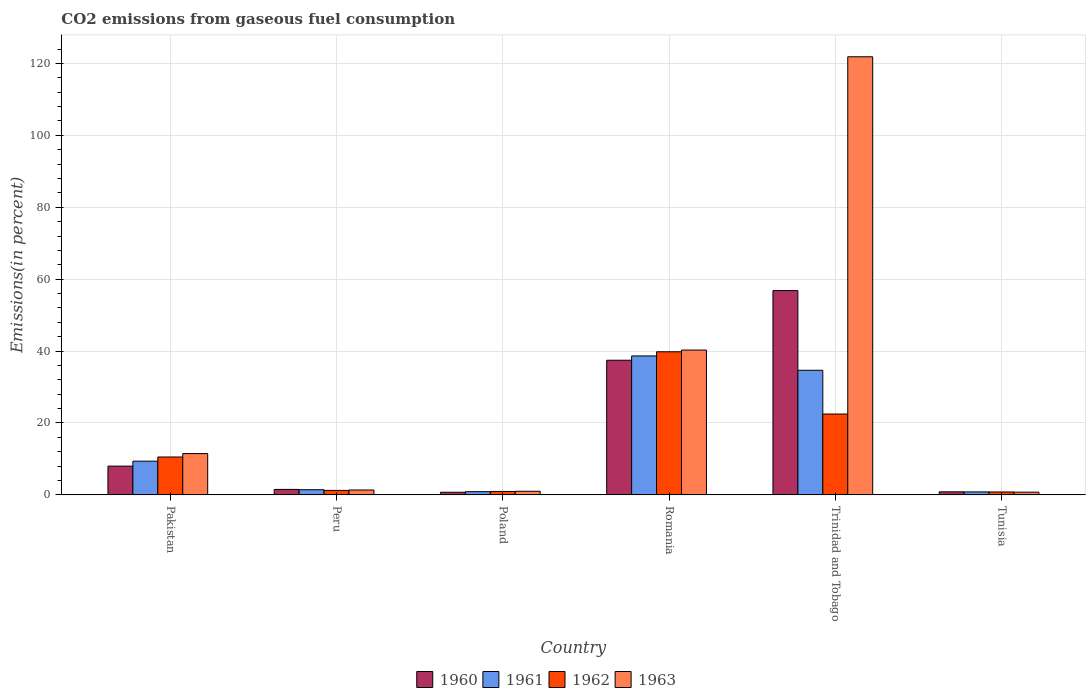Are the number of bars per tick equal to the number of legend labels?
Offer a very short reply. Yes. How many bars are there on the 6th tick from the right?
Provide a succinct answer. 4. What is the label of the 5th group of bars from the left?
Make the answer very short. Trinidad and Tobago. What is the total CO2 emitted in 1961 in Romania?
Provide a short and direct response. 38.65. Across all countries, what is the maximum total CO2 emitted in 1960?
Give a very brief answer. 56.82. Across all countries, what is the minimum total CO2 emitted in 1961?
Your answer should be very brief. 0.83. In which country was the total CO2 emitted in 1962 maximum?
Provide a succinct answer. Romania. In which country was the total CO2 emitted in 1963 minimum?
Provide a succinct answer. Tunisia. What is the total total CO2 emitted in 1963 in the graph?
Provide a short and direct response. 176.75. What is the difference between the total CO2 emitted in 1961 in Pakistan and that in Romania?
Your answer should be very brief. -29.26. What is the difference between the total CO2 emitted in 1960 in Romania and the total CO2 emitted in 1963 in Tunisia?
Keep it short and to the point. 36.7. What is the average total CO2 emitted in 1962 per country?
Your response must be concise. 12.64. What is the difference between the total CO2 emitted of/in 1963 and total CO2 emitted of/in 1962 in Romania?
Offer a terse response. 0.48. In how many countries, is the total CO2 emitted in 1961 greater than 44 %?
Your answer should be very brief. 0. What is the ratio of the total CO2 emitted in 1963 in Peru to that in Trinidad and Tobago?
Offer a very short reply. 0.01. Is the difference between the total CO2 emitted in 1963 in Romania and Tunisia greater than the difference between the total CO2 emitted in 1962 in Romania and Tunisia?
Ensure brevity in your answer.  Yes. What is the difference between the highest and the second highest total CO2 emitted in 1962?
Provide a short and direct response. -11.95. What is the difference between the highest and the lowest total CO2 emitted in 1960?
Offer a terse response. 56.08. Is it the case that in every country, the sum of the total CO2 emitted in 1963 and total CO2 emitted in 1961 is greater than the total CO2 emitted in 1962?
Give a very brief answer. Yes. How many bars are there?
Provide a succinct answer. 24. Are all the bars in the graph horizontal?
Your answer should be compact. No. What is the difference between two consecutive major ticks on the Y-axis?
Make the answer very short. 20. Are the values on the major ticks of Y-axis written in scientific E-notation?
Your answer should be very brief. No. Does the graph contain any zero values?
Your response must be concise. No. Where does the legend appear in the graph?
Your answer should be compact. Bottom center. How many legend labels are there?
Offer a terse response. 4. What is the title of the graph?
Offer a very short reply. CO2 emissions from gaseous fuel consumption. Does "1993" appear as one of the legend labels in the graph?
Keep it short and to the point. No. What is the label or title of the Y-axis?
Offer a terse response. Emissions(in percent). What is the Emissions(in percent) of 1960 in Pakistan?
Provide a short and direct response. 8.01. What is the Emissions(in percent) of 1961 in Pakistan?
Keep it short and to the point. 9.38. What is the Emissions(in percent) of 1962 in Pakistan?
Your answer should be compact. 10.54. What is the Emissions(in percent) in 1963 in Pakistan?
Keep it short and to the point. 11.49. What is the Emissions(in percent) of 1960 in Peru?
Make the answer very short. 1.53. What is the Emissions(in percent) in 1961 in Peru?
Ensure brevity in your answer.  1.44. What is the Emissions(in percent) of 1962 in Peru?
Offer a very short reply. 1.25. What is the Emissions(in percent) of 1963 in Peru?
Provide a succinct answer. 1.36. What is the Emissions(in percent) of 1960 in Poland?
Offer a very short reply. 0.74. What is the Emissions(in percent) in 1961 in Poland?
Provide a short and direct response. 0.89. What is the Emissions(in percent) in 1962 in Poland?
Keep it short and to the point. 0.96. What is the Emissions(in percent) of 1963 in Poland?
Give a very brief answer. 1.01. What is the Emissions(in percent) of 1960 in Romania?
Your answer should be very brief. 37.45. What is the Emissions(in percent) of 1961 in Romania?
Your response must be concise. 38.65. What is the Emissions(in percent) of 1962 in Romania?
Give a very brief answer. 39.8. What is the Emissions(in percent) of 1963 in Romania?
Offer a terse response. 40.28. What is the Emissions(in percent) of 1960 in Trinidad and Tobago?
Your answer should be compact. 56.82. What is the Emissions(in percent) in 1961 in Trinidad and Tobago?
Your response must be concise. 34.66. What is the Emissions(in percent) in 1962 in Trinidad and Tobago?
Provide a short and direct response. 22.49. What is the Emissions(in percent) of 1963 in Trinidad and Tobago?
Offer a terse response. 121.85. What is the Emissions(in percent) in 1960 in Tunisia?
Ensure brevity in your answer.  0.85. What is the Emissions(in percent) of 1961 in Tunisia?
Ensure brevity in your answer.  0.83. What is the Emissions(in percent) of 1962 in Tunisia?
Make the answer very short. 0.82. What is the Emissions(in percent) of 1963 in Tunisia?
Give a very brief answer. 0.75. Across all countries, what is the maximum Emissions(in percent) of 1960?
Your answer should be compact. 56.82. Across all countries, what is the maximum Emissions(in percent) of 1961?
Ensure brevity in your answer.  38.65. Across all countries, what is the maximum Emissions(in percent) of 1962?
Make the answer very short. 39.8. Across all countries, what is the maximum Emissions(in percent) in 1963?
Give a very brief answer. 121.85. Across all countries, what is the minimum Emissions(in percent) of 1960?
Give a very brief answer. 0.74. Across all countries, what is the minimum Emissions(in percent) in 1961?
Keep it short and to the point. 0.83. Across all countries, what is the minimum Emissions(in percent) in 1962?
Provide a succinct answer. 0.82. Across all countries, what is the minimum Emissions(in percent) in 1963?
Provide a succinct answer. 0.75. What is the total Emissions(in percent) of 1960 in the graph?
Your answer should be compact. 105.39. What is the total Emissions(in percent) of 1961 in the graph?
Provide a short and direct response. 85.86. What is the total Emissions(in percent) of 1962 in the graph?
Your answer should be compact. 75.86. What is the total Emissions(in percent) of 1963 in the graph?
Your answer should be very brief. 176.75. What is the difference between the Emissions(in percent) of 1960 in Pakistan and that in Peru?
Offer a very short reply. 6.48. What is the difference between the Emissions(in percent) in 1961 in Pakistan and that in Peru?
Offer a terse response. 7.94. What is the difference between the Emissions(in percent) of 1962 in Pakistan and that in Peru?
Make the answer very short. 9.29. What is the difference between the Emissions(in percent) in 1963 in Pakistan and that in Peru?
Provide a short and direct response. 10.13. What is the difference between the Emissions(in percent) in 1960 in Pakistan and that in Poland?
Offer a very short reply. 7.27. What is the difference between the Emissions(in percent) of 1961 in Pakistan and that in Poland?
Your response must be concise. 8.49. What is the difference between the Emissions(in percent) of 1962 in Pakistan and that in Poland?
Offer a very short reply. 9.58. What is the difference between the Emissions(in percent) in 1963 in Pakistan and that in Poland?
Give a very brief answer. 10.47. What is the difference between the Emissions(in percent) in 1960 in Pakistan and that in Romania?
Offer a very short reply. -29.45. What is the difference between the Emissions(in percent) in 1961 in Pakistan and that in Romania?
Provide a succinct answer. -29.26. What is the difference between the Emissions(in percent) in 1962 in Pakistan and that in Romania?
Ensure brevity in your answer.  -29.26. What is the difference between the Emissions(in percent) of 1963 in Pakistan and that in Romania?
Your answer should be compact. -28.8. What is the difference between the Emissions(in percent) of 1960 in Pakistan and that in Trinidad and Tobago?
Make the answer very short. -48.81. What is the difference between the Emissions(in percent) of 1961 in Pakistan and that in Trinidad and Tobago?
Make the answer very short. -25.28. What is the difference between the Emissions(in percent) in 1962 in Pakistan and that in Trinidad and Tobago?
Your answer should be compact. -11.95. What is the difference between the Emissions(in percent) in 1963 in Pakistan and that in Trinidad and Tobago?
Offer a terse response. -110.36. What is the difference between the Emissions(in percent) of 1960 in Pakistan and that in Tunisia?
Your response must be concise. 7.16. What is the difference between the Emissions(in percent) of 1961 in Pakistan and that in Tunisia?
Ensure brevity in your answer.  8.55. What is the difference between the Emissions(in percent) of 1962 in Pakistan and that in Tunisia?
Keep it short and to the point. 9.73. What is the difference between the Emissions(in percent) in 1963 in Pakistan and that in Tunisia?
Keep it short and to the point. 10.73. What is the difference between the Emissions(in percent) of 1960 in Peru and that in Poland?
Provide a short and direct response. 0.79. What is the difference between the Emissions(in percent) in 1961 in Peru and that in Poland?
Your answer should be very brief. 0.55. What is the difference between the Emissions(in percent) in 1962 in Peru and that in Poland?
Keep it short and to the point. 0.29. What is the difference between the Emissions(in percent) of 1963 in Peru and that in Poland?
Your response must be concise. 0.35. What is the difference between the Emissions(in percent) of 1960 in Peru and that in Romania?
Your answer should be very brief. -35.93. What is the difference between the Emissions(in percent) of 1961 in Peru and that in Romania?
Make the answer very short. -37.2. What is the difference between the Emissions(in percent) in 1962 in Peru and that in Romania?
Offer a terse response. -38.55. What is the difference between the Emissions(in percent) in 1963 in Peru and that in Romania?
Provide a short and direct response. -38.92. What is the difference between the Emissions(in percent) of 1960 in Peru and that in Trinidad and Tobago?
Offer a terse response. -55.29. What is the difference between the Emissions(in percent) of 1961 in Peru and that in Trinidad and Tobago?
Your answer should be compact. -33.22. What is the difference between the Emissions(in percent) in 1962 in Peru and that in Trinidad and Tobago?
Provide a short and direct response. -21.24. What is the difference between the Emissions(in percent) in 1963 in Peru and that in Trinidad and Tobago?
Offer a terse response. -120.49. What is the difference between the Emissions(in percent) of 1960 in Peru and that in Tunisia?
Ensure brevity in your answer.  0.68. What is the difference between the Emissions(in percent) of 1961 in Peru and that in Tunisia?
Keep it short and to the point. 0.61. What is the difference between the Emissions(in percent) in 1962 in Peru and that in Tunisia?
Provide a succinct answer. 0.43. What is the difference between the Emissions(in percent) of 1963 in Peru and that in Tunisia?
Your answer should be compact. 0.61. What is the difference between the Emissions(in percent) of 1960 in Poland and that in Romania?
Ensure brevity in your answer.  -36.72. What is the difference between the Emissions(in percent) in 1961 in Poland and that in Romania?
Your answer should be very brief. -37.75. What is the difference between the Emissions(in percent) in 1962 in Poland and that in Romania?
Offer a terse response. -38.85. What is the difference between the Emissions(in percent) in 1963 in Poland and that in Romania?
Your answer should be very brief. -39.27. What is the difference between the Emissions(in percent) in 1960 in Poland and that in Trinidad and Tobago?
Keep it short and to the point. -56.08. What is the difference between the Emissions(in percent) in 1961 in Poland and that in Trinidad and Tobago?
Give a very brief answer. -33.77. What is the difference between the Emissions(in percent) in 1962 in Poland and that in Trinidad and Tobago?
Keep it short and to the point. -21.53. What is the difference between the Emissions(in percent) of 1963 in Poland and that in Trinidad and Tobago?
Provide a short and direct response. -120.84. What is the difference between the Emissions(in percent) in 1960 in Poland and that in Tunisia?
Provide a succinct answer. -0.11. What is the difference between the Emissions(in percent) of 1961 in Poland and that in Tunisia?
Provide a short and direct response. 0.06. What is the difference between the Emissions(in percent) of 1962 in Poland and that in Tunisia?
Give a very brief answer. 0.14. What is the difference between the Emissions(in percent) in 1963 in Poland and that in Tunisia?
Offer a very short reply. 0.26. What is the difference between the Emissions(in percent) of 1960 in Romania and that in Trinidad and Tobago?
Your answer should be compact. -19.37. What is the difference between the Emissions(in percent) in 1961 in Romania and that in Trinidad and Tobago?
Make the answer very short. 3.98. What is the difference between the Emissions(in percent) in 1962 in Romania and that in Trinidad and Tobago?
Offer a terse response. 17.31. What is the difference between the Emissions(in percent) in 1963 in Romania and that in Trinidad and Tobago?
Give a very brief answer. -81.57. What is the difference between the Emissions(in percent) of 1960 in Romania and that in Tunisia?
Offer a terse response. 36.6. What is the difference between the Emissions(in percent) of 1961 in Romania and that in Tunisia?
Make the answer very short. 37.82. What is the difference between the Emissions(in percent) in 1962 in Romania and that in Tunisia?
Your answer should be compact. 38.99. What is the difference between the Emissions(in percent) of 1963 in Romania and that in Tunisia?
Your response must be concise. 39.53. What is the difference between the Emissions(in percent) in 1960 in Trinidad and Tobago and that in Tunisia?
Provide a short and direct response. 55.97. What is the difference between the Emissions(in percent) of 1961 in Trinidad and Tobago and that in Tunisia?
Your answer should be very brief. 33.83. What is the difference between the Emissions(in percent) in 1962 in Trinidad and Tobago and that in Tunisia?
Provide a short and direct response. 21.68. What is the difference between the Emissions(in percent) in 1963 in Trinidad and Tobago and that in Tunisia?
Your answer should be very brief. 121.1. What is the difference between the Emissions(in percent) in 1960 in Pakistan and the Emissions(in percent) in 1961 in Peru?
Keep it short and to the point. 6.56. What is the difference between the Emissions(in percent) of 1960 in Pakistan and the Emissions(in percent) of 1962 in Peru?
Offer a terse response. 6.75. What is the difference between the Emissions(in percent) in 1960 in Pakistan and the Emissions(in percent) in 1963 in Peru?
Your response must be concise. 6.64. What is the difference between the Emissions(in percent) of 1961 in Pakistan and the Emissions(in percent) of 1962 in Peru?
Your answer should be very brief. 8.13. What is the difference between the Emissions(in percent) of 1961 in Pakistan and the Emissions(in percent) of 1963 in Peru?
Make the answer very short. 8.02. What is the difference between the Emissions(in percent) of 1962 in Pakistan and the Emissions(in percent) of 1963 in Peru?
Ensure brevity in your answer.  9.18. What is the difference between the Emissions(in percent) of 1960 in Pakistan and the Emissions(in percent) of 1961 in Poland?
Your answer should be very brief. 7.11. What is the difference between the Emissions(in percent) in 1960 in Pakistan and the Emissions(in percent) in 1962 in Poland?
Your response must be concise. 7.05. What is the difference between the Emissions(in percent) of 1960 in Pakistan and the Emissions(in percent) of 1963 in Poland?
Give a very brief answer. 6.99. What is the difference between the Emissions(in percent) of 1961 in Pakistan and the Emissions(in percent) of 1962 in Poland?
Offer a very short reply. 8.42. What is the difference between the Emissions(in percent) in 1961 in Pakistan and the Emissions(in percent) in 1963 in Poland?
Make the answer very short. 8.37. What is the difference between the Emissions(in percent) in 1962 in Pakistan and the Emissions(in percent) in 1963 in Poland?
Give a very brief answer. 9.53. What is the difference between the Emissions(in percent) of 1960 in Pakistan and the Emissions(in percent) of 1961 in Romania?
Keep it short and to the point. -30.64. What is the difference between the Emissions(in percent) of 1960 in Pakistan and the Emissions(in percent) of 1962 in Romania?
Provide a succinct answer. -31.8. What is the difference between the Emissions(in percent) in 1960 in Pakistan and the Emissions(in percent) in 1963 in Romania?
Your answer should be very brief. -32.28. What is the difference between the Emissions(in percent) in 1961 in Pakistan and the Emissions(in percent) in 1962 in Romania?
Provide a succinct answer. -30.42. What is the difference between the Emissions(in percent) of 1961 in Pakistan and the Emissions(in percent) of 1963 in Romania?
Your response must be concise. -30.9. What is the difference between the Emissions(in percent) of 1962 in Pakistan and the Emissions(in percent) of 1963 in Romania?
Provide a succinct answer. -29.74. What is the difference between the Emissions(in percent) in 1960 in Pakistan and the Emissions(in percent) in 1961 in Trinidad and Tobago?
Your answer should be very brief. -26.66. What is the difference between the Emissions(in percent) in 1960 in Pakistan and the Emissions(in percent) in 1962 in Trinidad and Tobago?
Provide a succinct answer. -14.49. What is the difference between the Emissions(in percent) of 1960 in Pakistan and the Emissions(in percent) of 1963 in Trinidad and Tobago?
Ensure brevity in your answer.  -113.84. What is the difference between the Emissions(in percent) of 1961 in Pakistan and the Emissions(in percent) of 1962 in Trinidad and Tobago?
Your response must be concise. -13.11. What is the difference between the Emissions(in percent) of 1961 in Pakistan and the Emissions(in percent) of 1963 in Trinidad and Tobago?
Give a very brief answer. -112.47. What is the difference between the Emissions(in percent) in 1962 in Pakistan and the Emissions(in percent) in 1963 in Trinidad and Tobago?
Offer a terse response. -111.31. What is the difference between the Emissions(in percent) of 1960 in Pakistan and the Emissions(in percent) of 1961 in Tunisia?
Offer a terse response. 7.18. What is the difference between the Emissions(in percent) in 1960 in Pakistan and the Emissions(in percent) in 1962 in Tunisia?
Keep it short and to the point. 7.19. What is the difference between the Emissions(in percent) in 1960 in Pakistan and the Emissions(in percent) in 1963 in Tunisia?
Provide a succinct answer. 7.25. What is the difference between the Emissions(in percent) in 1961 in Pakistan and the Emissions(in percent) in 1962 in Tunisia?
Your answer should be compact. 8.57. What is the difference between the Emissions(in percent) in 1961 in Pakistan and the Emissions(in percent) in 1963 in Tunisia?
Offer a very short reply. 8.63. What is the difference between the Emissions(in percent) in 1962 in Pakistan and the Emissions(in percent) in 1963 in Tunisia?
Your answer should be very brief. 9.79. What is the difference between the Emissions(in percent) in 1960 in Peru and the Emissions(in percent) in 1961 in Poland?
Your answer should be compact. 0.63. What is the difference between the Emissions(in percent) of 1960 in Peru and the Emissions(in percent) of 1962 in Poland?
Your answer should be compact. 0.57. What is the difference between the Emissions(in percent) in 1960 in Peru and the Emissions(in percent) in 1963 in Poland?
Keep it short and to the point. 0.51. What is the difference between the Emissions(in percent) of 1961 in Peru and the Emissions(in percent) of 1962 in Poland?
Keep it short and to the point. 0.48. What is the difference between the Emissions(in percent) of 1961 in Peru and the Emissions(in percent) of 1963 in Poland?
Provide a succinct answer. 0.43. What is the difference between the Emissions(in percent) in 1962 in Peru and the Emissions(in percent) in 1963 in Poland?
Your response must be concise. 0.24. What is the difference between the Emissions(in percent) in 1960 in Peru and the Emissions(in percent) in 1961 in Romania?
Your answer should be compact. -37.12. What is the difference between the Emissions(in percent) of 1960 in Peru and the Emissions(in percent) of 1962 in Romania?
Offer a terse response. -38.28. What is the difference between the Emissions(in percent) in 1960 in Peru and the Emissions(in percent) in 1963 in Romania?
Offer a very short reply. -38.76. What is the difference between the Emissions(in percent) in 1961 in Peru and the Emissions(in percent) in 1962 in Romania?
Offer a very short reply. -38.36. What is the difference between the Emissions(in percent) in 1961 in Peru and the Emissions(in percent) in 1963 in Romania?
Provide a succinct answer. -38.84. What is the difference between the Emissions(in percent) of 1962 in Peru and the Emissions(in percent) of 1963 in Romania?
Keep it short and to the point. -39.03. What is the difference between the Emissions(in percent) in 1960 in Peru and the Emissions(in percent) in 1961 in Trinidad and Tobago?
Offer a very short reply. -33.14. What is the difference between the Emissions(in percent) of 1960 in Peru and the Emissions(in percent) of 1962 in Trinidad and Tobago?
Your answer should be compact. -20.97. What is the difference between the Emissions(in percent) of 1960 in Peru and the Emissions(in percent) of 1963 in Trinidad and Tobago?
Your answer should be very brief. -120.32. What is the difference between the Emissions(in percent) in 1961 in Peru and the Emissions(in percent) in 1962 in Trinidad and Tobago?
Ensure brevity in your answer.  -21.05. What is the difference between the Emissions(in percent) in 1961 in Peru and the Emissions(in percent) in 1963 in Trinidad and Tobago?
Your answer should be compact. -120.41. What is the difference between the Emissions(in percent) in 1962 in Peru and the Emissions(in percent) in 1963 in Trinidad and Tobago?
Provide a short and direct response. -120.6. What is the difference between the Emissions(in percent) of 1960 in Peru and the Emissions(in percent) of 1961 in Tunisia?
Keep it short and to the point. 0.7. What is the difference between the Emissions(in percent) in 1960 in Peru and the Emissions(in percent) in 1962 in Tunisia?
Your response must be concise. 0.71. What is the difference between the Emissions(in percent) of 1960 in Peru and the Emissions(in percent) of 1963 in Tunisia?
Make the answer very short. 0.77. What is the difference between the Emissions(in percent) in 1961 in Peru and the Emissions(in percent) in 1962 in Tunisia?
Your answer should be very brief. 0.63. What is the difference between the Emissions(in percent) of 1961 in Peru and the Emissions(in percent) of 1963 in Tunisia?
Offer a terse response. 0.69. What is the difference between the Emissions(in percent) of 1962 in Peru and the Emissions(in percent) of 1963 in Tunisia?
Keep it short and to the point. 0.5. What is the difference between the Emissions(in percent) in 1960 in Poland and the Emissions(in percent) in 1961 in Romania?
Provide a short and direct response. -37.91. What is the difference between the Emissions(in percent) of 1960 in Poland and the Emissions(in percent) of 1962 in Romania?
Ensure brevity in your answer.  -39.07. What is the difference between the Emissions(in percent) in 1960 in Poland and the Emissions(in percent) in 1963 in Romania?
Your answer should be very brief. -39.55. What is the difference between the Emissions(in percent) of 1961 in Poland and the Emissions(in percent) of 1962 in Romania?
Your response must be concise. -38.91. What is the difference between the Emissions(in percent) of 1961 in Poland and the Emissions(in percent) of 1963 in Romania?
Make the answer very short. -39.39. What is the difference between the Emissions(in percent) of 1962 in Poland and the Emissions(in percent) of 1963 in Romania?
Provide a short and direct response. -39.32. What is the difference between the Emissions(in percent) of 1960 in Poland and the Emissions(in percent) of 1961 in Trinidad and Tobago?
Keep it short and to the point. -33.93. What is the difference between the Emissions(in percent) in 1960 in Poland and the Emissions(in percent) in 1962 in Trinidad and Tobago?
Ensure brevity in your answer.  -21.76. What is the difference between the Emissions(in percent) in 1960 in Poland and the Emissions(in percent) in 1963 in Trinidad and Tobago?
Your answer should be compact. -121.11. What is the difference between the Emissions(in percent) of 1961 in Poland and the Emissions(in percent) of 1962 in Trinidad and Tobago?
Your answer should be compact. -21.6. What is the difference between the Emissions(in percent) in 1961 in Poland and the Emissions(in percent) in 1963 in Trinidad and Tobago?
Keep it short and to the point. -120.95. What is the difference between the Emissions(in percent) of 1962 in Poland and the Emissions(in percent) of 1963 in Trinidad and Tobago?
Ensure brevity in your answer.  -120.89. What is the difference between the Emissions(in percent) in 1960 in Poland and the Emissions(in percent) in 1961 in Tunisia?
Your response must be concise. -0.09. What is the difference between the Emissions(in percent) of 1960 in Poland and the Emissions(in percent) of 1962 in Tunisia?
Provide a short and direct response. -0.08. What is the difference between the Emissions(in percent) in 1960 in Poland and the Emissions(in percent) in 1963 in Tunisia?
Offer a very short reply. -0.02. What is the difference between the Emissions(in percent) of 1961 in Poland and the Emissions(in percent) of 1962 in Tunisia?
Provide a succinct answer. 0.08. What is the difference between the Emissions(in percent) in 1961 in Poland and the Emissions(in percent) in 1963 in Tunisia?
Ensure brevity in your answer.  0.14. What is the difference between the Emissions(in percent) of 1962 in Poland and the Emissions(in percent) of 1963 in Tunisia?
Make the answer very short. 0.21. What is the difference between the Emissions(in percent) of 1960 in Romania and the Emissions(in percent) of 1961 in Trinidad and Tobago?
Give a very brief answer. 2.79. What is the difference between the Emissions(in percent) in 1960 in Romania and the Emissions(in percent) in 1962 in Trinidad and Tobago?
Provide a succinct answer. 14.96. What is the difference between the Emissions(in percent) in 1960 in Romania and the Emissions(in percent) in 1963 in Trinidad and Tobago?
Give a very brief answer. -84.4. What is the difference between the Emissions(in percent) of 1961 in Romania and the Emissions(in percent) of 1962 in Trinidad and Tobago?
Your answer should be very brief. 16.15. What is the difference between the Emissions(in percent) of 1961 in Romania and the Emissions(in percent) of 1963 in Trinidad and Tobago?
Your response must be concise. -83.2. What is the difference between the Emissions(in percent) in 1962 in Romania and the Emissions(in percent) in 1963 in Trinidad and Tobago?
Your answer should be very brief. -82.04. What is the difference between the Emissions(in percent) in 1960 in Romania and the Emissions(in percent) in 1961 in Tunisia?
Your answer should be compact. 36.62. What is the difference between the Emissions(in percent) in 1960 in Romania and the Emissions(in percent) in 1962 in Tunisia?
Your answer should be compact. 36.64. What is the difference between the Emissions(in percent) in 1960 in Romania and the Emissions(in percent) in 1963 in Tunisia?
Offer a very short reply. 36.7. What is the difference between the Emissions(in percent) of 1961 in Romania and the Emissions(in percent) of 1962 in Tunisia?
Provide a succinct answer. 37.83. What is the difference between the Emissions(in percent) of 1961 in Romania and the Emissions(in percent) of 1963 in Tunisia?
Keep it short and to the point. 37.89. What is the difference between the Emissions(in percent) of 1962 in Romania and the Emissions(in percent) of 1963 in Tunisia?
Keep it short and to the point. 39.05. What is the difference between the Emissions(in percent) of 1960 in Trinidad and Tobago and the Emissions(in percent) of 1961 in Tunisia?
Give a very brief answer. 55.99. What is the difference between the Emissions(in percent) of 1960 in Trinidad and Tobago and the Emissions(in percent) of 1962 in Tunisia?
Your answer should be compact. 56. What is the difference between the Emissions(in percent) of 1960 in Trinidad and Tobago and the Emissions(in percent) of 1963 in Tunisia?
Offer a very short reply. 56.06. What is the difference between the Emissions(in percent) of 1961 in Trinidad and Tobago and the Emissions(in percent) of 1962 in Tunisia?
Keep it short and to the point. 33.84. What is the difference between the Emissions(in percent) in 1961 in Trinidad and Tobago and the Emissions(in percent) in 1963 in Tunisia?
Keep it short and to the point. 33.91. What is the difference between the Emissions(in percent) of 1962 in Trinidad and Tobago and the Emissions(in percent) of 1963 in Tunisia?
Your answer should be very brief. 21.74. What is the average Emissions(in percent) of 1960 per country?
Make the answer very short. 17.56. What is the average Emissions(in percent) in 1961 per country?
Provide a succinct answer. 14.31. What is the average Emissions(in percent) of 1962 per country?
Your answer should be very brief. 12.64. What is the average Emissions(in percent) of 1963 per country?
Your response must be concise. 29.46. What is the difference between the Emissions(in percent) of 1960 and Emissions(in percent) of 1961 in Pakistan?
Ensure brevity in your answer.  -1.38. What is the difference between the Emissions(in percent) of 1960 and Emissions(in percent) of 1962 in Pakistan?
Ensure brevity in your answer.  -2.54. What is the difference between the Emissions(in percent) in 1960 and Emissions(in percent) in 1963 in Pakistan?
Your response must be concise. -3.48. What is the difference between the Emissions(in percent) in 1961 and Emissions(in percent) in 1962 in Pakistan?
Make the answer very short. -1.16. What is the difference between the Emissions(in percent) in 1961 and Emissions(in percent) in 1963 in Pakistan?
Give a very brief answer. -2.11. What is the difference between the Emissions(in percent) of 1962 and Emissions(in percent) of 1963 in Pakistan?
Your response must be concise. -0.95. What is the difference between the Emissions(in percent) of 1960 and Emissions(in percent) of 1961 in Peru?
Offer a terse response. 0.08. What is the difference between the Emissions(in percent) of 1960 and Emissions(in percent) of 1962 in Peru?
Ensure brevity in your answer.  0.27. What is the difference between the Emissions(in percent) in 1960 and Emissions(in percent) in 1963 in Peru?
Offer a very short reply. 0.16. What is the difference between the Emissions(in percent) of 1961 and Emissions(in percent) of 1962 in Peru?
Provide a succinct answer. 0.19. What is the difference between the Emissions(in percent) in 1961 and Emissions(in percent) in 1963 in Peru?
Give a very brief answer. 0.08. What is the difference between the Emissions(in percent) of 1962 and Emissions(in percent) of 1963 in Peru?
Your response must be concise. -0.11. What is the difference between the Emissions(in percent) in 1960 and Emissions(in percent) in 1961 in Poland?
Give a very brief answer. -0.16. What is the difference between the Emissions(in percent) in 1960 and Emissions(in percent) in 1962 in Poland?
Ensure brevity in your answer.  -0.22. What is the difference between the Emissions(in percent) of 1960 and Emissions(in percent) of 1963 in Poland?
Your response must be concise. -0.28. What is the difference between the Emissions(in percent) in 1961 and Emissions(in percent) in 1962 in Poland?
Keep it short and to the point. -0.06. What is the difference between the Emissions(in percent) of 1961 and Emissions(in percent) of 1963 in Poland?
Your answer should be compact. -0.12. What is the difference between the Emissions(in percent) of 1962 and Emissions(in percent) of 1963 in Poland?
Your answer should be compact. -0.05. What is the difference between the Emissions(in percent) of 1960 and Emissions(in percent) of 1961 in Romania?
Give a very brief answer. -1.19. What is the difference between the Emissions(in percent) in 1960 and Emissions(in percent) in 1962 in Romania?
Keep it short and to the point. -2.35. What is the difference between the Emissions(in percent) in 1960 and Emissions(in percent) in 1963 in Romania?
Provide a short and direct response. -2.83. What is the difference between the Emissions(in percent) in 1961 and Emissions(in percent) in 1962 in Romania?
Ensure brevity in your answer.  -1.16. What is the difference between the Emissions(in percent) in 1961 and Emissions(in percent) in 1963 in Romania?
Offer a terse response. -1.64. What is the difference between the Emissions(in percent) in 1962 and Emissions(in percent) in 1963 in Romania?
Your answer should be very brief. -0.48. What is the difference between the Emissions(in percent) of 1960 and Emissions(in percent) of 1961 in Trinidad and Tobago?
Provide a short and direct response. 22.16. What is the difference between the Emissions(in percent) in 1960 and Emissions(in percent) in 1962 in Trinidad and Tobago?
Your response must be concise. 34.33. What is the difference between the Emissions(in percent) of 1960 and Emissions(in percent) of 1963 in Trinidad and Tobago?
Your answer should be very brief. -65.03. What is the difference between the Emissions(in percent) of 1961 and Emissions(in percent) of 1962 in Trinidad and Tobago?
Offer a terse response. 12.17. What is the difference between the Emissions(in percent) of 1961 and Emissions(in percent) of 1963 in Trinidad and Tobago?
Give a very brief answer. -87.19. What is the difference between the Emissions(in percent) of 1962 and Emissions(in percent) of 1963 in Trinidad and Tobago?
Offer a terse response. -99.36. What is the difference between the Emissions(in percent) in 1960 and Emissions(in percent) in 1961 in Tunisia?
Offer a terse response. 0.02. What is the difference between the Emissions(in percent) of 1960 and Emissions(in percent) of 1962 in Tunisia?
Keep it short and to the point. 0.03. What is the difference between the Emissions(in percent) in 1960 and Emissions(in percent) in 1963 in Tunisia?
Keep it short and to the point. 0.1. What is the difference between the Emissions(in percent) in 1961 and Emissions(in percent) in 1962 in Tunisia?
Offer a terse response. 0.01. What is the difference between the Emissions(in percent) in 1961 and Emissions(in percent) in 1963 in Tunisia?
Provide a succinct answer. 0.08. What is the difference between the Emissions(in percent) of 1962 and Emissions(in percent) of 1963 in Tunisia?
Your response must be concise. 0.06. What is the ratio of the Emissions(in percent) in 1960 in Pakistan to that in Peru?
Make the answer very short. 5.25. What is the ratio of the Emissions(in percent) in 1961 in Pakistan to that in Peru?
Provide a succinct answer. 6.5. What is the ratio of the Emissions(in percent) of 1962 in Pakistan to that in Peru?
Offer a terse response. 8.43. What is the ratio of the Emissions(in percent) of 1963 in Pakistan to that in Peru?
Your response must be concise. 8.44. What is the ratio of the Emissions(in percent) in 1960 in Pakistan to that in Poland?
Offer a terse response. 10.88. What is the ratio of the Emissions(in percent) of 1961 in Pakistan to that in Poland?
Provide a succinct answer. 10.49. What is the ratio of the Emissions(in percent) in 1962 in Pakistan to that in Poland?
Keep it short and to the point. 10.99. What is the ratio of the Emissions(in percent) of 1963 in Pakistan to that in Poland?
Provide a succinct answer. 11.34. What is the ratio of the Emissions(in percent) of 1960 in Pakistan to that in Romania?
Your answer should be very brief. 0.21. What is the ratio of the Emissions(in percent) of 1961 in Pakistan to that in Romania?
Give a very brief answer. 0.24. What is the ratio of the Emissions(in percent) in 1962 in Pakistan to that in Romania?
Your answer should be very brief. 0.26. What is the ratio of the Emissions(in percent) in 1963 in Pakistan to that in Romania?
Provide a short and direct response. 0.29. What is the ratio of the Emissions(in percent) in 1960 in Pakistan to that in Trinidad and Tobago?
Provide a succinct answer. 0.14. What is the ratio of the Emissions(in percent) in 1961 in Pakistan to that in Trinidad and Tobago?
Your response must be concise. 0.27. What is the ratio of the Emissions(in percent) in 1962 in Pakistan to that in Trinidad and Tobago?
Your response must be concise. 0.47. What is the ratio of the Emissions(in percent) of 1963 in Pakistan to that in Trinidad and Tobago?
Ensure brevity in your answer.  0.09. What is the ratio of the Emissions(in percent) of 1960 in Pakistan to that in Tunisia?
Your response must be concise. 9.43. What is the ratio of the Emissions(in percent) in 1961 in Pakistan to that in Tunisia?
Your response must be concise. 11.31. What is the ratio of the Emissions(in percent) in 1962 in Pakistan to that in Tunisia?
Your answer should be very brief. 12.91. What is the ratio of the Emissions(in percent) in 1963 in Pakistan to that in Tunisia?
Your response must be concise. 15.25. What is the ratio of the Emissions(in percent) of 1960 in Peru to that in Poland?
Offer a terse response. 2.07. What is the ratio of the Emissions(in percent) in 1961 in Peru to that in Poland?
Provide a succinct answer. 1.61. What is the ratio of the Emissions(in percent) in 1962 in Peru to that in Poland?
Provide a succinct answer. 1.3. What is the ratio of the Emissions(in percent) in 1963 in Peru to that in Poland?
Keep it short and to the point. 1.34. What is the ratio of the Emissions(in percent) in 1960 in Peru to that in Romania?
Offer a terse response. 0.04. What is the ratio of the Emissions(in percent) in 1961 in Peru to that in Romania?
Keep it short and to the point. 0.04. What is the ratio of the Emissions(in percent) of 1962 in Peru to that in Romania?
Your response must be concise. 0.03. What is the ratio of the Emissions(in percent) in 1963 in Peru to that in Romania?
Provide a short and direct response. 0.03. What is the ratio of the Emissions(in percent) in 1960 in Peru to that in Trinidad and Tobago?
Provide a short and direct response. 0.03. What is the ratio of the Emissions(in percent) in 1961 in Peru to that in Trinidad and Tobago?
Offer a very short reply. 0.04. What is the ratio of the Emissions(in percent) in 1962 in Peru to that in Trinidad and Tobago?
Keep it short and to the point. 0.06. What is the ratio of the Emissions(in percent) of 1963 in Peru to that in Trinidad and Tobago?
Provide a succinct answer. 0.01. What is the ratio of the Emissions(in percent) of 1960 in Peru to that in Tunisia?
Offer a terse response. 1.8. What is the ratio of the Emissions(in percent) in 1961 in Peru to that in Tunisia?
Your response must be concise. 1.74. What is the ratio of the Emissions(in percent) in 1962 in Peru to that in Tunisia?
Provide a short and direct response. 1.53. What is the ratio of the Emissions(in percent) in 1963 in Peru to that in Tunisia?
Your answer should be compact. 1.81. What is the ratio of the Emissions(in percent) in 1960 in Poland to that in Romania?
Offer a terse response. 0.02. What is the ratio of the Emissions(in percent) of 1961 in Poland to that in Romania?
Provide a succinct answer. 0.02. What is the ratio of the Emissions(in percent) of 1962 in Poland to that in Romania?
Offer a very short reply. 0.02. What is the ratio of the Emissions(in percent) in 1963 in Poland to that in Romania?
Provide a short and direct response. 0.03. What is the ratio of the Emissions(in percent) of 1960 in Poland to that in Trinidad and Tobago?
Provide a succinct answer. 0.01. What is the ratio of the Emissions(in percent) of 1961 in Poland to that in Trinidad and Tobago?
Offer a very short reply. 0.03. What is the ratio of the Emissions(in percent) of 1962 in Poland to that in Trinidad and Tobago?
Offer a very short reply. 0.04. What is the ratio of the Emissions(in percent) in 1963 in Poland to that in Trinidad and Tobago?
Make the answer very short. 0.01. What is the ratio of the Emissions(in percent) in 1960 in Poland to that in Tunisia?
Offer a very short reply. 0.87. What is the ratio of the Emissions(in percent) in 1961 in Poland to that in Tunisia?
Your answer should be very brief. 1.08. What is the ratio of the Emissions(in percent) of 1962 in Poland to that in Tunisia?
Your response must be concise. 1.17. What is the ratio of the Emissions(in percent) of 1963 in Poland to that in Tunisia?
Provide a short and direct response. 1.35. What is the ratio of the Emissions(in percent) in 1960 in Romania to that in Trinidad and Tobago?
Ensure brevity in your answer.  0.66. What is the ratio of the Emissions(in percent) in 1961 in Romania to that in Trinidad and Tobago?
Ensure brevity in your answer.  1.11. What is the ratio of the Emissions(in percent) in 1962 in Romania to that in Trinidad and Tobago?
Keep it short and to the point. 1.77. What is the ratio of the Emissions(in percent) in 1963 in Romania to that in Trinidad and Tobago?
Make the answer very short. 0.33. What is the ratio of the Emissions(in percent) in 1960 in Romania to that in Tunisia?
Your answer should be compact. 44.1. What is the ratio of the Emissions(in percent) in 1961 in Romania to that in Tunisia?
Provide a short and direct response. 46.57. What is the ratio of the Emissions(in percent) of 1962 in Romania to that in Tunisia?
Your response must be concise. 48.76. What is the ratio of the Emissions(in percent) in 1963 in Romania to that in Tunisia?
Make the answer very short. 53.48. What is the ratio of the Emissions(in percent) in 1960 in Trinidad and Tobago to that in Tunisia?
Provide a succinct answer. 66.9. What is the ratio of the Emissions(in percent) in 1961 in Trinidad and Tobago to that in Tunisia?
Ensure brevity in your answer.  41.77. What is the ratio of the Emissions(in percent) in 1962 in Trinidad and Tobago to that in Tunisia?
Provide a short and direct response. 27.55. What is the ratio of the Emissions(in percent) in 1963 in Trinidad and Tobago to that in Tunisia?
Your answer should be very brief. 161.75. What is the difference between the highest and the second highest Emissions(in percent) of 1960?
Your response must be concise. 19.37. What is the difference between the highest and the second highest Emissions(in percent) in 1961?
Make the answer very short. 3.98. What is the difference between the highest and the second highest Emissions(in percent) in 1962?
Keep it short and to the point. 17.31. What is the difference between the highest and the second highest Emissions(in percent) in 1963?
Ensure brevity in your answer.  81.57. What is the difference between the highest and the lowest Emissions(in percent) in 1960?
Keep it short and to the point. 56.08. What is the difference between the highest and the lowest Emissions(in percent) in 1961?
Provide a short and direct response. 37.82. What is the difference between the highest and the lowest Emissions(in percent) of 1962?
Give a very brief answer. 38.99. What is the difference between the highest and the lowest Emissions(in percent) of 1963?
Offer a terse response. 121.1. 